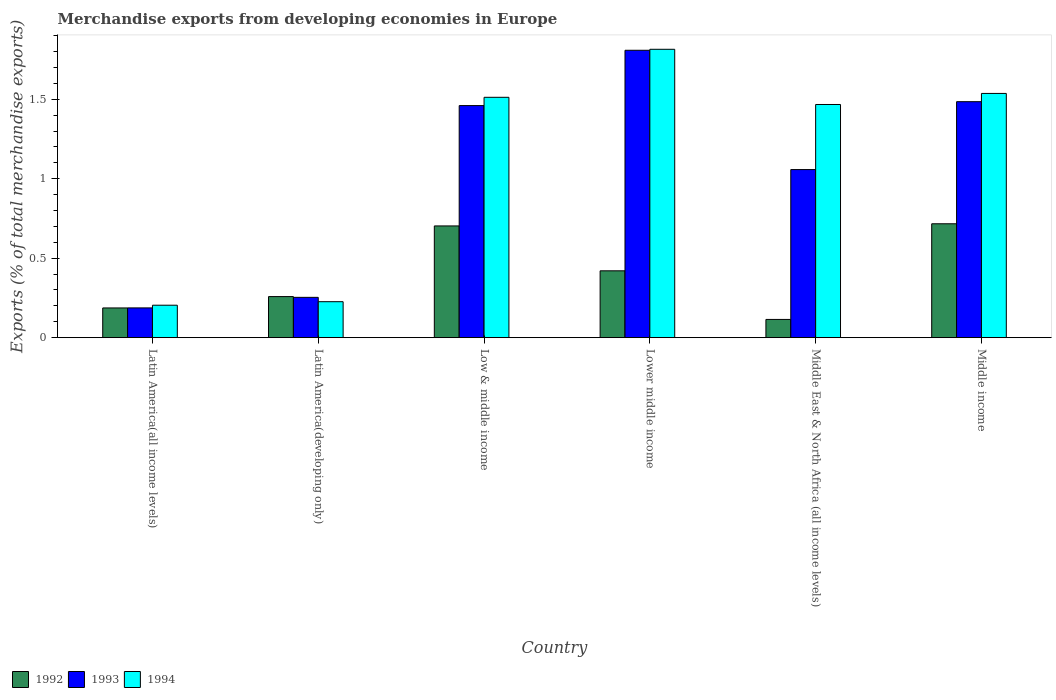How many groups of bars are there?
Ensure brevity in your answer.  6. Are the number of bars per tick equal to the number of legend labels?
Ensure brevity in your answer.  Yes. How many bars are there on the 4th tick from the right?
Provide a short and direct response. 3. In how many cases, is the number of bars for a given country not equal to the number of legend labels?
Offer a terse response. 0. What is the percentage of total merchandise exports in 1994 in Latin America(all income levels)?
Offer a terse response. 0.2. Across all countries, what is the maximum percentage of total merchandise exports in 1993?
Provide a succinct answer. 1.81. Across all countries, what is the minimum percentage of total merchandise exports in 1994?
Your answer should be very brief. 0.2. In which country was the percentage of total merchandise exports in 1993 maximum?
Offer a very short reply. Lower middle income. In which country was the percentage of total merchandise exports in 1994 minimum?
Offer a terse response. Latin America(all income levels). What is the total percentage of total merchandise exports in 1993 in the graph?
Provide a short and direct response. 6.25. What is the difference between the percentage of total merchandise exports in 1993 in Latin America(all income levels) and that in Latin America(developing only)?
Offer a terse response. -0.07. What is the difference between the percentage of total merchandise exports in 1993 in Lower middle income and the percentage of total merchandise exports in 1994 in Middle East & North Africa (all income levels)?
Your answer should be compact. 0.34. What is the average percentage of total merchandise exports in 1994 per country?
Make the answer very short. 1.13. What is the difference between the percentage of total merchandise exports of/in 1992 and percentage of total merchandise exports of/in 1994 in Latin America(all income levels)?
Your answer should be very brief. -0.02. What is the ratio of the percentage of total merchandise exports in 1993 in Latin America(developing only) to that in Low & middle income?
Provide a short and direct response. 0.17. What is the difference between the highest and the second highest percentage of total merchandise exports in 1994?
Your response must be concise. -0.3. What is the difference between the highest and the lowest percentage of total merchandise exports in 1992?
Provide a short and direct response. 0.6. Is the sum of the percentage of total merchandise exports in 1994 in Lower middle income and Middle income greater than the maximum percentage of total merchandise exports in 1992 across all countries?
Provide a short and direct response. Yes. How many countries are there in the graph?
Your answer should be compact. 6. What is the difference between two consecutive major ticks on the Y-axis?
Make the answer very short. 0.5. Does the graph contain any zero values?
Your answer should be very brief. No. Does the graph contain grids?
Offer a terse response. No. Where does the legend appear in the graph?
Your response must be concise. Bottom left. How many legend labels are there?
Your answer should be compact. 3. What is the title of the graph?
Offer a very short reply. Merchandise exports from developing economies in Europe. What is the label or title of the X-axis?
Make the answer very short. Country. What is the label or title of the Y-axis?
Give a very brief answer. Exports (% of total merchandise exports). What is the Exports (% of total merchandise exports) of 1992 in Latin America(all income levels)?
Your answer should be very brief. 0.19. What is the Exports (% of total merchandise exports) of 1993 in Latin America(all income levels)?
Provide a short and direct response. 0.19. What is the Exports (% of total merchandise exports) of 1994 in Latin America(all income levels)?
Keep it short and to the point. 0.2. What is the Exports (% of total merchandise exports) in 1992 in Latin America(developing only)?
Offer a terse response. 0.26. What is the Exports (% of total merchandise exports) of 1993 in Latin America(developing only)?
Provide a succinct answer. 0.25. What is the Exports (% of total merchandise exports) of 1994 in Latin America(developing only)?
Your response must be concise. 0.23. What is the Exports (% of total merchandise exports) in 1992 in Low & middle income?
Offer a very short reply. 0.7. What is the Exports (% of total merchandise exports) in 1993 in Low & middle income?
Your answer should be compact. 1.46. What is the Exports (% of total merchandise exports) of 1994 in Low & middle income?
Your response must be concise. 1.51. What is the Exports (% of total merchandise exports) in 1992 in Lower middle income?
Make the answer very short. 0.42. What is the Exports (% of total merchandise exports) of 1993 in Lower middle income?
Give a very brief answer. 1.81. What is the Exports (% of total merchandise exports) in 1994 in Lower middle income?
Offer a terse response. 1.81. What is the Exports (% of total merchandise exports) in 1992 in Middle East & North Africa (all income levels)?
Offer a very short reply. 0.11. What is the Exports (% of total merchandise exports) in 1993 in Middle East & North Africa (all income levels)?
Offer a very short reply. 1.06. What is the Exports (% of total merchandise exports) in 1994 in Middle East & North Africa (all income levels)?
Provide a succinct answer. 1.47. What is the Exports (% of total merchandise exports) of 1992 in Middle income?
Give a very brief answer. 0.72. What is the Exports (% of total merchandise exports) of 1993 in Middle income?
Offer a very short reply. 1.48. What is the Exports (% of total merchandise exports) in 1994 in Middle income?
Your answer should be compact. 1.54. Across all countries, what is the maximum Exports (% of total merchandise exports) of 1992?
Offer a terse response. 0.72. Across all countries, what is the maximum Exports (% of total merchandise exports) in 1993?
Give a very brief answer. 1.81. Across all countries, what is the maximum Exports (% of total merchandise exports) of 1994?
Provide a short and direct response. 1.81. Across all countries, what is the minimum Exports (% of total merchandise exports) in 1992?
Your response must be concise. 0.11. Across all countries, what is the minimum Exports (% of total merchandise exports) of 1993?
Provide a short and direct response. 0.19. Across all countries, what is the minimum Exports (% of total merchandise exports) of 1994?
Provide a succinct answer. 0.2. What is the total Exports (% of total merchandise exports) of 1992 in the graph?
Your answer should be compact. 2.4. What is the total Exports (% of total merchandise exports) in 1993 in the graph?
Make the answer very short. 6.25. What is the total Exports (% of total merchandise exports) in 1994 in the graph?
Keep it short and to the point. 6.76. What is the difference between the Exports (% of total merchandise exports) of 1992 in Latin America(all income levels) and that in Latin America(developing only)?
Provide a short and direct response. -0.07. What is the difference between the Exports (% of total merchandise exports) of 1993 in Latin America(all income levels) and that in Latin America(developing only)?
Your answer should be compact. -0.07. What is the difference between the Exports (% of total merchandise exports) of 1994 in Latin America(all income levels) and that in Latin America(developing only)?
Offer a terse response. -0.02. What is the difference between the Exports (% of total merchandise exports) of 1992 in Latin America(all income levels) and that in Low & middle income?
Keep it short and to the point. -0.52. What is the difference between the Exports (% of total merchandise exports) of 1993 in Latin America(all income levels) and that in Low & middle income?
Your response must be concise. -1.27. What is the difference between the Exports (% of total merchandise exports) in 1994 in Latin America(all income levels) and that in Low & middle income?
Your answer should be very brief. -1.31. What is the difference between the Exports (% of total merchandise exports) in 1992 in Latin America(all income levels) and that in Lower middle income?
Make the answer very short. -0.23. What is the difference between the Exports (% of total merchandise exports) in 1993 in Latin America(all income levels) and that in Lower middle income?
Keep it short and to the point. -1.62. What is the difference between the Exports (% of total merchandise exports) in 1994 in Latin America(all income levels) and that in Lower middle income?
Provide a short and direct response. -1.61. What is the difference between the Exports (% of total merchandise exports) in 1992 in Latin America(all income levels) and that in Middle East & North Africa (all income levels)?
Your response must be concise. 0.07. What is the difference between the Exports (% of total merchandise exports) in 1993 in Latin America(all income levels) and that in Middle East & North Africa (all income levels)?
Ensure brevity in your answer.  -0.87. What is the difference between the Exports (% of total merchandise exports) of 1994 in Latin America(all income levels) and that in Middle East & North Africa (all income levels)?
Your answer should be very brief. -1.26. What is the difference between the Exports (% of total merchandise exports) of 1992 in Latin America(all income levels) and that in Middle income?
Give a very brief answer. -0.53. What is the difference between the Exports (% of total merchandise exports) of 1993 in Latin America(all income levels) and that in Middle income?
Offer a terse response. -1.3. What is the difference between the Exports (% of total merchandise exports) of 1994 in Latin America(all income levels) and that in Middle income?
Provide a succinct answer. -1.33. What is the difference between the Exports (% of total merchandise exports) of 1992 in Latin America(developing only) and that in Low & middle income?
Your answer should be very brief. -0.44. What is the difference between the Exports (% of total merchandise exports) of 1993 in Latin America(developing only) and that in Low & middle income?
Provide a short and direct response. -1.21. What is the difference between the Exports (% of total merchandise exports) of 1994 in Latin America(developing only) and that in Low & middle income?
Make the answer very short. -1.29. What is the difference between the Exports (% of total merchandise exports) of 1992 in Latin America(developing only) and that in Lower middle income?
Provide a short and direct response. -0.16. What is the difference between the Exports (% of total merchandise exports) in 1993 in Latin America(developing only) and that in Lower middle income?
Give a very brief answer. -1.55. What is the difference between the Exports (% of total merchandise exports) of 1994 in Latin America(developing only) and that in Lower middle income?
Provide a succinct answer. -1.59. What is the difference between the Exports (% of total merchandise exports) of 1992 in Latin America(developing only) and that in Middle East & North Africa (all income levels)?
Provide a short and direct response. 0.14. What is the difference between the Exports (% of total merchandise exports) in 1993 in Latin America(developing only) and that in Middle East & North Africa (all income levels)?
Ensure brevity in your answer.  -0.8. What is the difference between the Exports (% of total merchandise exports) in 1994 in Latin America(developing only) and that in Middle East & North Africa (all income levels)?
Your answer should be very brief. -1.24. What is the difference between the Exports (% of total merchandise exports) of 1992 in Latin America(developing only) and that in Middle income?
Your response must be concise. -0.46. What is the difference between the Exports (% of total merchandise exports) of 1993 in Latin America(developing only) and that in Middle income?
Offer a terse response. -1.23. What is the difference between the Exports (% of total merchandise exports) of 1994 in Latin America(developing only) and that in Middle income?
Offer a very short reply. -1.31. What is the difference between the Exports (% of total merchandise exports) in 1992 in Low & middle income and that in Lower middle income?
Your answer should be compact. 0.28. What is the difference between the Exports (% of total merchandise exports) in 1993 in Low & middle income and that in Lower middle income?
Your answer should be very brief. -0.35. What is the difference between the Exports (% of total merchandise exports) in 1994 in Low & middle income and that in Lower middle income?
Provide a succinct answer. -0.3. What is the difference between the Exports (% of total merchandise exports) of 1992 in Low & middle income and that in Middle East & North Africa (all income levels)?
Offer a terse response. 0.59. What is the difference between the Exports (% of total merchandise exports) of 1993 in Low & middle income and that in Middle East & North Africa (all income levels)?
Your response must be concise. 0.4. What is the difference between the Exports (% of total merchandise exports) of 1994 in Low & middle income and that in Middle East & North Africa (all income levels)?
Offer a terse response. 0.05. What is the difference between the Exports (% of total merchandise exports) of 1992 in Low & middle income and that in Middle income?
Offer a terse response. -0.01. What is the difference between the Exports (% of total merchandise exports) of 1993 in Low & middle income and that in Middle income?
Offer a very short reply. -0.02. What is the difference between the Exports (% of total merchandise exports) in 1994 in Low & middle income and that in Middle income?
Provide a short and direct response. -0.02. What is the difference between the Exports (% of total merchandise exports) in 1992 in Lower middle income and that in Middle East & North Africa (all income levels)?
Your response must be concise. 0.31. What is the difference between the Exports (% of total merchandise exports) of 1993 in Lower middle income and that in Middle East & North Africa (all income levels)?
Keep it short and to the point. 0.75. What is the difference between the Exports (% of total merchandise exports) of 1994 in Lower middle income and that in Middle East & North Africa (all income levels)?
Your response must be concise. 0.35. What is the difference between the Exports (% of total merchandise exports) of 1992 in Lower middle income and that in Middle income?
Keep it short and to the point. -0.3. What is the difference between the Exports (% of total merchandise exports) of 1993 in Lower middle income and that in Middle income?
Offer a terse response. 0.32. What is the difference between the Exports (% of total merchandise exports) in 1994 in Lower middle income and that in Middle income?
Ensure brevity in your answer.  0.28. What is the difference between the Exports (% of total merchandise exports) of 1992 in Middle East & North Africa (all income levels) and that in Middle income?
Offer a very short reply. -0.6. What is the difference between the Exports (% of total merchandise exports) in 1993 in Middle East & North Africa (all income levels) and that in Middle income?
Your answer should be compact. -0.43. What is the difference between the Exports (% of total merchandise exports) in 1994 in Middle East & North Africa (all income levels) and that in Middle income?
Offer a terse response. -0.07. What is the difference between the Exports (% of total merchandise exports) in 1992 in Latin America(all income levels) and the Exports (% of total merchandise exports) in 1993 in Latin America(developing only)?
Make the answer very short. -0.07. What is the difference between the Exports (% of total merchandise exports) in 1992 in Latin America(all income levels) and the Exports (% of total merchandise exports) in 1994 in Latin America(developing only)?
Your answer should be compact. -0.04. What is the difference between the Exports (% of total merchandise exports) in 1993 in Latin America(all income levels) and the Exports (% of total merchandise exports) in 1994 in Latin America(developing only)?
Provide a short and direct response. -0.04. What is the difference between the Exports (% of total merchandise exports) in 1992 in Latin America(all income levels) and the Exports (% of total merchandise exports) in 1993 in Low & middle income?
Offer a terse response. -1.27. What is the difference between the Exports (% of total merchandise exports) of 1992 in Latin America(all income levels) and the Exports (% of total merchandise exports) of 1994 in Low & middle income?
Provide a succinct answer. -1.33. What is the difference between the Exports (% of total merchandise exports) in 1993 in Latin America(all income levels) and the Exports (% of total merchandise exports) in 1994 in Low & middle income?
Your answer should be compact. -1.32. What is the difference between the Exports (% of total merchandise exports) in 1992 in Latin America(all income levels) and the Exports (% of total merchandise exports) in 1993 in Lower middle income?
Your response must be concise. -1.62. What is the difference between the Exports (% of total merchandise exports) in 1992 in Latin America(all income levels) and the Exports (% of total merchandise exports) in 1994 in Lower middle income?
Provide a succinct answer. -1.63. What is the difference between the Exports (% of total merchandise exports) in 1993 in Latin America(all income levels) and the Exports (% of total merchandise exports) in 1994 in Lower middle income?
Provide a succinct answer. -1.63. What is the difference between the Exports (% of total merchandise exports) in 1992 in Latin America(all income levels) and the Exports (% of total merchandise exports) in 1993 in Middle East & North Africa (all income levels)?
Provide a short and direct response. -0.87. What is the difference between the Exports (% of total merchandise exports) of 1992 in Latin America(all income levels) and the Exports (% of total merchandise exports) of 1994 in Middle East & North Africa (all income levels)?
Provide a short and direct response. -1.28. What is the difference between the Exports (% of total merchandise exports) of 1993 in Latin America(all income levels) and the Exports (% of total merchandise exports) of 1994 in Middle East & North Africa (all income levels)?
Provide a succinct answer. -1.28. What is the difference between the Exports (% of total merchandise exports) of 1992 in Latin America(all income levels) and the Exports (% of total merchandise exports) of 1993 in Middle income?
Offer a terse response. -1.3. What is the difference between the Exports (% of total merchandise exports) of 1992 in Latin America(all income levels) and the Exports (% of total merchandise exports) of 1994 in Middle income?
Keep it short and to the point. -1.35. What is the difference between the Exports (% of total merchandise exports) of 1993 in Latin America(all income levels) and the Exports (% of total merchandise exports) of 1994 in Middle income?
Ensure brevity in your answer.  -1.35. What is the difference between the Exports (% of total merchandise exports) in 1992 in Latin America(developing only) and the Exports (% of total merchandise exports) in 1993 in Low & middle income?
Your response must be concise. -1.2. What is the difference between the Exports (% of total merchandise exports) of 1992 in Latin America(developing only) and the Exports (% of total merchandise exports) of 1994 in Low & middle income?
Make the answer very short. -1.25. What is the difference between the Exports (% of total merchandise exports) of 1993 in Latin America(developing only) and the Exports (% of total merchandise exports) of 1994 in Low & middle income?
Your answer should be compact. -1.26. What is the difference between the Exports (% of total merchandise exports) in 1992 in Latin America(developing only) and the Exports (% of total merchandise exports) in 1993 in Lower middle income?
Offer a terse response. -1.55. What is the difference between the Exports (% of total merchandise exports) of 1992 in Latin America(developing only) and the Exports (% of total merchandise exports) of 1994 in Lower middle income?
Your response must be concise. -1.56. What is the difference between the Exports (% of total merchandise exports) in 1993 in Latin America(developing only) and the Exports (% of total merchandise exports) in 1994 in Lower middle income?
Offer a very short reply. -1.56. What is the difference between the Exports (% of total merchandise exports) in 1992 in Latin America(developing only) and the Exports (% of total merchandise exports) in 1993 in Middle East & North Africa (all income levels)?
Your answer should be very brief. -0.8. What is the difference between the Exports (% of total merchandise exports) in 1992 in Latin America(developing only) and the Exports (% of total merchandise exports) in 1994 in Middle East & North Africa (all income levels)?
Offer a very short reply. -1.21. What is the difference between the Exports (% of total merchandise exports) in 1993 in Latin America(developing only) and the Exports (% of total merchandise exports) in 1994 in Middle East & North Africa (all income levels)?
Offer a very short reply. -1.21. What is the difference between the Exports (% of total merchandise exports) of 1992 in Latin America(developing only) and the Exports (% of total merchandise exports) of 1993 in Middle income?
Offer a terse response. -1.23. What is the difference between the Exports (% of total merchandise exports) in 1992 in Latin America(developing only) and the Exports (% of total merchandise exports) in 1994 in Middle income?
Make the answer very short. -1.28. What is the difference between the Exports (% of total merchandise exports) in 1993 in Latin America(developing only) and the Exports (% of total merchandise exports) in 1994 in Middle income?
Keep it short and to the point. -1.28. What is the difference between the Exports (% of total merchandise exports) of 1992 in Low & middle income and the Exports (% of total merchandise exports) of 1993 in Lower middle income?
Make the answer very short. -1.11. What is the difference between the Exports (% of total merchandise exports) of 1992 in Low & middle income and the Exports (% of total merchandise exports) of 1994 in Lower middle income?
Offer a terse response. -1.11. What is the difference between the Exports (% of total merchandise exports) in 1993 in Low & middle income and the Exports (% of total merchandise exports) in 1994 in Lower middle income?
Make the answer very short. -0.35. What is the difference between the Exports (% of total merchandise exports) of 1992 in Low & middle income and the Exports (% of total merchandise exports) of 1993 in Middle East & North Africa (all income levels)?
Offer a very short reply. -0.35. What is the difference between the Exports (% of total merchandise exports) in 1992 in Low & middle income and the Exports (% of total merchandise exports) in 1994 in Middle East & North Africa (all income levels)?
Your response must be concise. -0.76. What is the difference between the Exports (% of total merchandise exports) in 1993 in Low & middle income and the Exports (% of total merchandise exports) in 1994 in Middle East & North Africa (all income levels)?
Your response must be concise. -0.01. What is the difference between the Exports (% of total merchandise exports) of 1992 in Low & middle income and the Exports (% of total merchandise exports) of 1993 in Middle income?
Make the answer very short. -0.78. What is the difference between the Exports (% of total merchandise exports) in 1992 in Low & middle income and the Exports (% of total merchandise exports) in 1994 in Middle income?
Offer a very short reply. -0.83. What is the difference between the Exports (% of total merchandise exports) in 1993 in Low & middle income and the Exports (% of total merchandise exports) in 1994 in Middle income?
Provide a short and direct response. -0.08. What is the difference between the Exports (% of total merchandise exports) of 1992 in Lower middle income and the Exports (% of total merchandise exports) of 1993 in Middle East & North Africa (all income levels)?
Offer a very short reply. -0.64. What is the difference between the Exports (% of total merchandise exports) in 1992 in Lower middle income and the Exports (% of total merchandise exports) in 1994 in Middle East & North Africa (all income levels)?
Your response must be concise. -1.05. What is the difference between the Exports (% of total merchandise exports) of 1993 in Lower middle income and the Exports (% of total merchandise exports) of 1994 in Middle East & North Africa (all income levels)?
Make the answer very short. 0.34. What is the difference between the Exports (% of total merchandise exports) in 1992 in Lower middle income and the Exports (% of total merchandise exports) in 1993 in Middle income?
Your answer should be compact. -1.06. What is the difference between the Exports (% of total merchandise exports) in 1992 in Lower middle income and the Exports (% of total merchandise exports) in 1994 in Middle income?
Make the answer very short. -1.12. What is the difference between the Exports (% of total merchandise exports) in 1993 in Lower middle income and the Exports (% of total merchandise exports) in 1994 in Middle income?
Ensure brevity in your answer.  0.27. What is the difference between the Exports (% of total merchandise exports) in 1992 in Middle East & North Africa (all income levels) and the Exports (% of total merchandise exports) in 1993 in Middle income?
Make the answer very short. -1.37. What is the difference between the Exports (% of total merchandise exports) in 1992 in Middle East & North Africa (all income levels) and the Exports (% of total merchandise exports) in 1994 in Middle income?
Your response must be concise. -1.42. What is the difference between the Exports (% of total merchandise exports) in 1993 in Middle East & North Africa (all income levels) and the Exports (% of total merchandise exports) in 1994 in Middle income?
Your answer should be compact. -0.48. What is the average Exports (% of total merchandise exports) in 1992 per country?
Offer a terse response. 0.4. What is the average Exports (% of total merchandise exports) in 1993 per country?
Keep it short and to the point. 1.04. What is the average Exports (% of total merchandise exports) in 1994 per country?
Make the answer very short. 1.13. What is the difference between the Exports (% of total merchandise exports) of 1992 and Exports (% of total merchandise exports) of 1993 in Latin America(all income levels)?
Provide a succinct answer. -0. What is the difference between the Exports (% of total merchandise exports) of 1992 and Exports (% of total merchandise exports) of 1994 in Latin America(all income levels)?
Your answer should be compact. -0.02. What is the difference between the Exports (% of total merchandise exports) of 1993 and Exports (% of total merchandise exports) of 1994 in Latin America(all income levels)?
Your answer should be very brief. -0.02. What is the difference between the Exports (% of total merchandise exports) of 1992 and Exports (% of total merchandise exports) of 1993 in Latin America(developing only)?
Give a very brief answer. 0. What is the difference between the Exports (% of total merchandise exports) of 1992 and Exports (% of total merchandise exports) of 1994 in Latin America(developing only)?
Offer a terse response. 0.03. What is the difference between the Exports (% of total merchandise exports) of 1993 and Exports (% of total merchandise exports) of 1994 in Latin America(developing only)?
Give a very brief answer. 0.03. What is the difference between the Exports (% of total merchandise exports) of 1992 and Exports (% of total merchandise exports) of 1993 in Low & middle income?
Give a very brief answer. -0.76. What is the difference between the Exports (% of total merchandise exports) of 1992 and Exports (% of total merchandise exports) of 1994 in Low & middle income?
Your answer should be compact. -0.81. What is the difference between the Exports (% of total merchandise exports) in 1993 and Exports (% of total merchandise exports) in 1994 in Low & middle income?
Give a very brief answer. -0.05. What is the difference between the Exports (% of total merchandise exports) of 1992 and Exports (% of total merchandise exports) of 1993 in Lower middle income?
Offer a very short reply. -1.39. What is the difference between the Exports (% of total merchandise exports) in 1992 and Exports (% of total merchandise exports) in 1994 in Lower middle income?
Ensure brevity in your answer.  -1.39. What is the difference between the Exports (% of total merchandise exports) in 1993 and Exports (% of total merchandise exports) in 1994 in Lower middle income?
Your response must be concise. -0.01. What is the difference between the Exports (% of total merchandise exports) of 1992 and Exports (% of total merchandise exports) of 1993 in Middle East & North Africa (all income levels)?
Keep it short and to the point. -0.94. What is the difference between the Exports (% of total merchandise exports) of 1992 and Exports (% of total merchandise exports) of 1994 in Middle East & North Africa (all income levels)?
Your response must be concise. -1.35. What is the difference between the Exports (% of total merchandise exports) of 1993 and Exports (% of total merchandise exports) of 1994 in Middle East & North Africa (all income levels)?
Provide a succinct answer. -0.41. What is the difference between the Exports (% of total merchandise exports) in 1992 and Exports (% of total merchandise exports) in 1993 in Middle income?
Offer a terse response. -0.77. What is the difference between the Exports (% of total merchandise exports) of 1992 and Exports (% of total merchandise exports) of 1994 in Middle income?
Your answer should be compact. -0.82. What is the difference between the Exports (% of total merchandise exports) in 1993 and Exports (% of total merchandise exports) in 1994 in Middle income?
Offer a terse response. -0.05. What is the ratio of the Exports (% of total merchandise exports) of 1992 in Latin America(all income levels) to that in Latin America(developing only)?
Your response must be concise. 0.72. What is the ratio of the Exports (% of total merchandise exports) of 1993 in Latin America(all income levels) to that in Latin America(developing only)?
Ensure brevity in your answer.  0.74. What is the ratio of the Exports (% of total merchandise exports) of 1994 in Latin America(all income levels) to that in Latin America(developing only)?
Ensure brevity in your answer.  0.9. What is the ratio of the Exports (% of total merchandise exports) of 1992 in Latin America(all income levels) to that in Low & middle income?
Keep it short and to the point. 0.27. What is the ratio of the Exports (% of total merchandise exports) of 1993 in Latin America(all income levels) to that in Low & middle income?
Ensure brevity in your answer.  0.13. What is the ratio of the Exports (% of total merchandise exports) in 1994 in Latin America(all income levels) to that in Low & middle income?
Make the answer very short. 0.14. What is the ratio of the Exports (% of total merchandise exports) of 1992 in Latin America(all income levels) to that in Lower middle income?
Ensure brevity in your answer.  0.44. What is the ratio of the Exports (% of total merchandise exports) in 1993 in Latin America(all income levels) to that in Lower middle income?
Offer a very short reply. 0.1. What is the ratio of the Exports (% of total merchandise exports) in 1994 in Latin America(all income levels) to that in Lower middle income?
Offer a very short reply. 0.11. What is the ratio of the Exports (% of total merchandise exports) of 1992 in Latin America(all income levels) to that in Middle East & North Africa (all income levels)?
Offer a very short reply. 1.63. What is the ratio of the Exports (% of total merchandise exports) of 1993 in Latin America(all income levels) to that in Middle East & North Africa (all income levels)?
Keep it short and to the point. 0.18. What is the ratio of the Exports (% of total merchandise exports) of 1994 in Latin America(all income levels) to that in Middle East & North Africa (all income levels)?
Offer a very short reply. 0.14. What is the ratio of the Exports (% of total merchandise exports) of 1992 in Latin America(all income levels) to that in Middle income?
Keep it short and to the point. 0.26. What is the ratio of the Exports (% of total merchandise exports) of 1993 in Latin America(all income levels) to that in Middle income?
Offer a terse response. 0.13. What is the ratio of the Exports (% of total merchandise exports) in 1994 in Latin America(all income levels) to that in Middle income?
Provide a succinct answer. 0.13. What is the ratio of the Exports (% of total merchandise exports) in 1992 in Latin America(developing only) to that in Low & middle income?
Provide a short and direct response. 0.37. What is the ratio of the Exports (% of total merchandise exports) in 1993 in Latin America(developing only) to that in Low & middle income?
Your answer should be compact. 0.17. What is the ratio of the Exports (% of total merchandise exports) of 1994 in Latin America(developing only) to that in Low & middle income?
Offer a terse response. 0.15. What is the ratio of the Exports (% of total merchandise exports) of 1992 in Latin America(developing only) to that in Lower middle income?
Offer a very short reply. 0.61. What is the ratio of the Exports (% of total merchandise exports) in 1993 in Latin America(developing only) to that in Lower middle income?
Offer a terse response. 0.14. What is the ratio of the Exports (% of total merchandise exports) of 1994 in Latin America(developing only) to that in Lower middle income?
Offer a terse response. 0.12. What is the ratio of the Exports (% of total merchandise exports) of 1992 in Latin America(developing only) to that in Middle East & North Africa (all income levels)?
Ensure brevity in your answer.  2.25. What is the ratio of the Exports (% of total merchandise exports) of 1993 in Latin America(developing only) to that in Middle East & North Africa (all income levels)?
Your answer should be compact. 0.24. What is the ratio of the Exports (% of total merchandise exports) of 1994 in Latin America(developing only) to that in Middle East & North Africa (all income levels)?
Make the answer very short. 0.15. What is the ratio of the Exports (% of total merchandise exports) of 1992 in Latin America(developing only) to that in Middle income?
Make the answer very short. 0.36. What is the ratio of the Exports (% of total merchandise exports) in 1993 in Latin America(developing only) to that in Middle income?
Offer a very short reply. 0.17. What is the ratio of the Exports (% of total merchandise exports) of 1994 in Latin America(developing only) to that in Middle income?
Your answer should be compact. 0.15. What is the ratio of the Exports (% of total merchandise exports) of 1992 in Low & middle income to that in Lower middle income?
Ensure brevity in your answer.  1.67. What is the ratio of the Exports (% of total merchandise exports) of 1993 in Low & middle income to that in Lower middle income?
Keep it short and to the point. 0.81. What is the ratio of the Exports (% of total merchandise exports) in 1994 in Low & middle income to that in Lower middle income?
Provide a succinct answer. 0.83. What is the ratio of the Exports (% of total merchandise exports) in 1992 in Low & middle income to that in Middle East & North Africa (all income levels)?
Your response must be concise. 6.13. What is the ratio of the Exports (% of total merchandise exports) in 1993 in Low & middle income to that in Middle East & North Africa (all income levels)?
Your response must be concise. 1.38. What is the ratio of the Exports (% of total merchandise exports) in 1994 in Low & middle income to that in Middle East & North Africa (all income levels)?
Your response must be concise. 1.03. What is the ratio of the Exports (% of total merchandise exports) of 1992 in Low & middle income to that in Middle income?
Ensure brevity in your answer.  0.98. What is the ratio of the Exports (% of total merchandise exports) in 1993 in Low & middle income to that in Middle income?
Your response must be concise. 0.98. What is the ratio of the Exports (% of total merchandise exports) in 1994 in Low & middle income to that in Middle income?
Your answer should be compact. 0.98. What is the ratio of the Exports (% of total merchandise exports) in 1992 in Lower middle income to that in Middle East & North Africa (all income levels)?
Keep it short and to the point. 3.67. What is the ratio of the Exports (% of total merchandise exports) in 1993 in Lower middle income to that in Middle East & North Africa (all income levels)?
Ensure brevity in your answer.  1.71. What is the ratio of the Exports (% of total merchandise exports) in 1994 in Lower middle income to that in Middle East & North Africa (all income levels)?
Your response must be concise. 1.24. What is the ratio of the Exports (% of total merchandise exports) in 1992 in Lower middle income to that in Middle income?
Make the answer very short. 0.59. What is the ratio of the Exports (% of total merchandise exports) of 1993 in Lower middle income to that in Middle income?
Your answer should be very brief. 1.22. What is the ratio of the Exports (% of total merchandise exports) of 1994 in Lower middle income to that in Middle income?
Make the answer very short. 1.18. What is the ratio of the Exports (% of total merchandise exports) in 1992 in Middle East & North Africa (all income levels) to that in Middle income?
Keep it short and to the point. 0.16. What is the ratio of the Exports (% of total merchandise exports) of 1993 in Middle East & North Africa (all income levels) to that in Middle income?
Your answer should be compact. 0.71. What is the ratio of the Exports (% of total merchandise exports) in 1994 in Middle East & North Africa (all income levels) to that in Middle income?
Provide a succinct answer. 0.95. What is the difference between the highest and the second highest Exports (% of total merchandise exports) in 1992?
Give a very brief answer. 0.01. What is the difference between the highest and the second highest Exports (% of total merchandise exports) in 1993?
Offer a terse response. 0.32. What is the difference between the highest and the second highest Exports (% of total merchandise exports) of 1994?
Provide a short and direct response. 0.28. What is the difference between the highest and the lowest Exports (% of total merchandise exports) of 1992?
Your answer should be compact. 0.6. What is the difference between the highest and the lowest Exports (% of total merchandise exports) in 1993?
Make the answer very short. 1.62. What is the difference between the highest and the lowest Exports (% of total merchandise exports) of 1994?
Provide a short and direct response. 1.61. 